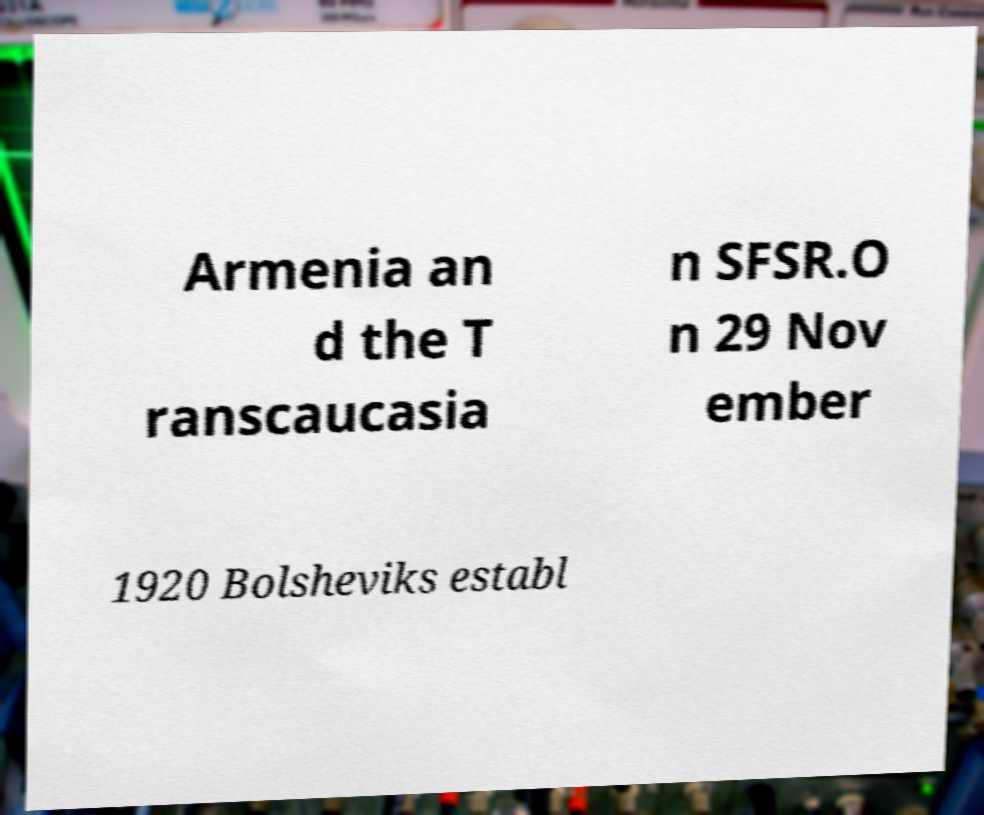Please read and relay the text visible in this image. What does it say? Armenia an d the T ranscaucasia n SFSR.O n 29 Nov ember 1920 Bolsheviks establ 